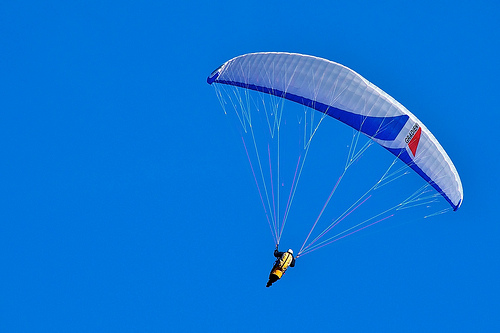Describe the scene in detail. In the image, a person is engaging in paragliding, soaring through a clear and vivid blue sky. They are holding onto cords that are attached to the parachute above them. The person is equipped with a yellow vest and a helmet for safety. The parachute itself is elegantly spread, showcasing its vibrant colors as it catches the wind. What could the person be feeling at this moment? The person might be experiencing a mix of excitement and exhilaration, feeling the rush of wind against their face and the thrill of floating high above the ground. There could also be a sense of tranquility, enjoying the peaceful expanse of the clear blue sky. 